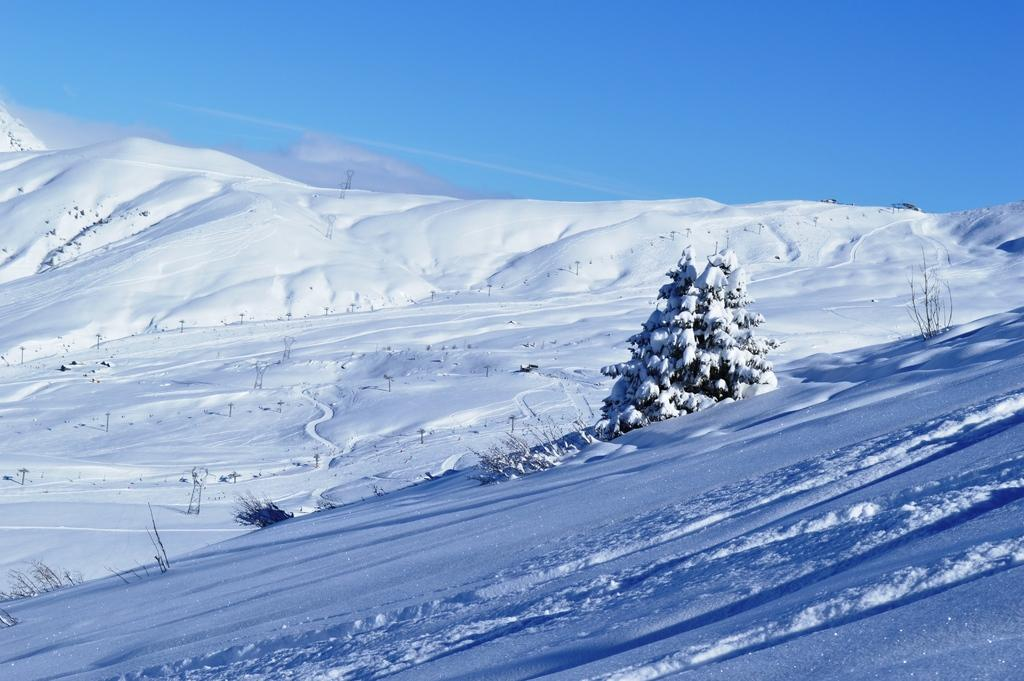What type of natural object can be seen in the image? There is a tree in the image. What is the overall appearance of the image due to? The image is fully covered with snow. What part of the natural environment is visible in the image? The sky is visible in the image. What type of birth can be seen taking place in the image? There is no birth taking place in the image; it features a tree covered in snow. What type of milk is being produced by the tree in the image? Trees do not produce milk, so this cannot be observed in the image. 